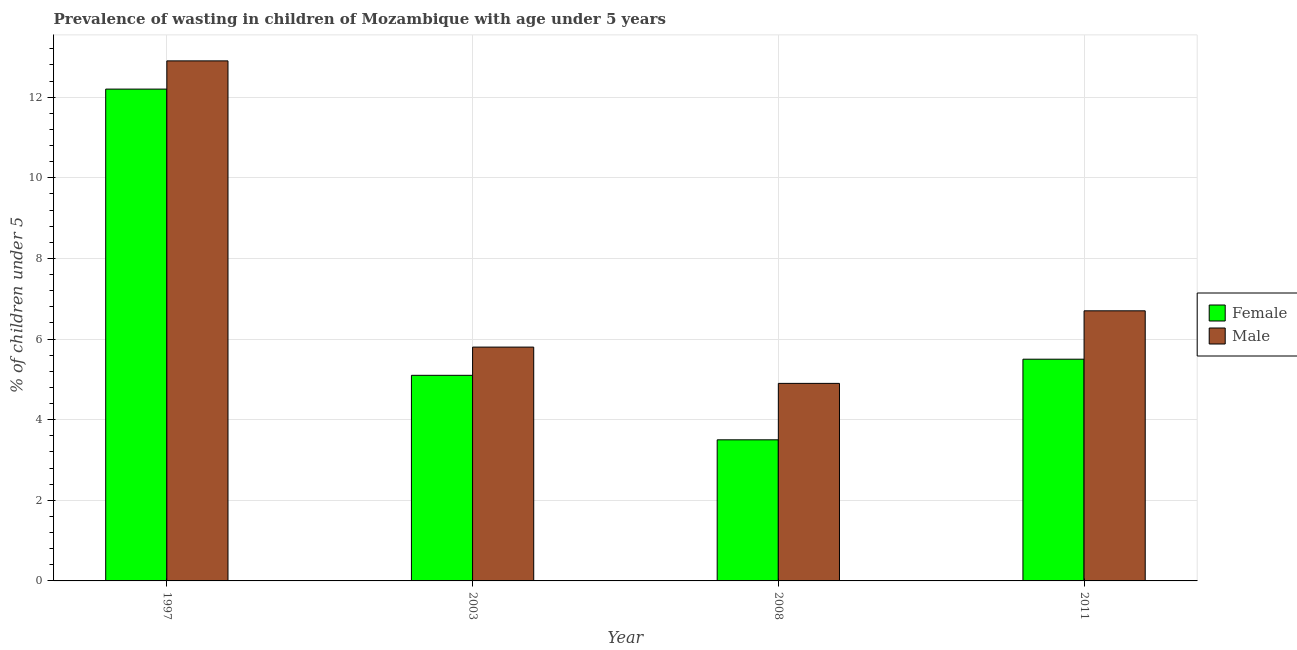How many different coloured bars are there?
Offer a very short reply. 2. How many groups of bars are there?
Offer a very short reply. 4. What is the percentage of undernourished female children in 2011?
Your response must be concise. 5.5. Across all years, what is the maximum percentage of undernourished female children?
Provide a succinct answer. 12.2. In which year was the percentage of undernourished male children maximum?
Your answer should be compact. 1997. In which year was the percentage of undernourished female children minimum?
Offer a very short reply. 2008. What is the total percentage of undernourished female children in the graph?
Your answer should be compact. 26.3. What is the difference between the percentage of undernourished female children in 1997 and that in 2008?
Ensure brevity in your answer.  8.7. What is the difference between the percentage of undernourished male children in 1997 and the percentage of undernourished female children in 2003?
Your response must be concise. 7.1. What is the average percentage of undernourished female children per year?
Your answer should be compact. 6.57. In how many years, is the percentage of undernourished female children greater than 2.8 %?
Offer a very short reply. 4. What is the ratio of the percentage of undernourished male children in 1997 to that in 2003?
Your answer should be very brief. 2.22. Is the percentage of undernourished male children in 2003 less than that in 2008?
Your answer should be very brief. No. What is the difference between the highest and the second highest percentage of undernourished male children?
Offer a terse response. 6.2. What is the difference between the highest and the lowest percentage of undernourished female children?
Keep it short and to the point. 8.7. In how many years, is the percentage of undernourished female children greater than the average percentage of undernourished female children taken over all years?
Provide a succinct answer. 1. Is the sum of the percentage of undernourished male children in 1997 and 2008 greater than the maximum percentage of undernourished female children across all years?
Your answer should be compact. Yes. What does the 2nd bar from the left in 1997 represents?
Your answer should be compact. Male. Are all the bars in the graph horizontal?
Ensure brevity in your answer.  No. How many years are there in the graph?
Your response must be concise. 4. Does the graph contain grids?
Give a very brief answer. Yes. Where does the legend appear in the graph?
Give a very brief answer. Center right. How many legend labels are there?
Give a very brief answer. 2. What is the title of the graph?
Your answer should be very brief. Prevalence of wasting in children of Mozambique with age under 5 years. Does "Private creditors" appear as one of the legend labels in the graph?
Your response must be concise. No. What is the label or title of the X-axis?
Give a very brief answer. Year. What is the label or title of the Y-axis?
Give a very brief answer.  % of children under 5. What is the  % of children under 5 of Female in 1997?
Provide a short and direct response. 12.2. What is the  % of children under 5 of Male in 1997?
Provide a succinct answer. 12.9. What is the  % of children under 5 of Female in 2003?
Ensure brevity in your answer.  5.1. What is the  % of children under 5 in Male in 2003?
Provide a short and direct response. 5.8. What is the  % of children under 5 of Male in 2008?
Your answer should be compact. 4.9. What is the  % of children under 5 of Female in 2011?
Provide a succinct answer. 5.5. What is the  % of children under 5 in Male in 2011?
Your response must be concise. 6.7. Across all years, what is the maximum  % of children under 5 in Female?
Your response must be concise. 12.2. Across all years, what is the maximum  % of children under 5 in Male?
Offer a very short reply. 12.9. Across all years, what is the minimum  % of children under 5 in Female?
Your answer should be very brief. 3.5. Across all years, what is the minimum  % of children under 5 of Male?
Offer a very short reply. 4.9. What is the total  % of children under 5 in Female in the graph?
Your answer should be very brief. 26.3. What is the total  % of children under 5 of Male in the graph?
Provide a succinct answer. 30.3. What is the difference between the  % of children under 5 in Female in 1997 and that in 2003?
Give a very brief answer. 7.1. What is the difference between the  % of children under 5 in Male in 1997 and that in 2003?
Your answer should be very brief. 7.1. What is the difference between the  % of children under 5 in Male in 1997 and that in 2008?
Provide a short and direct response. 8. What is the difference between the  % of children under 5 in Male in 1997 and that in 2011?
Keep it short and to the point. 6.2. What is the difference between the  % of children under 5 in Male in 2003 and that in 2008?
Keep it short and to the point. 0.9. What is the difference between the  % of children under 5 of Male in 2003 and that in 2011?
Give a very brief answer. -0.9. What is the difference between the  % of children under 5 in Female in 2008 and that in 2011?
Offer a very short reply. -2. What is the difference between the  % of children under 5 in Female in 1997 and the  % of children under 5 in Male in 2003?
Offer a very short reply. 6.4. What is the difference between the  % of children under 5 in Female in 1997 and the  % of children under 5 in Male in 2011?
Give a very brief answer. 5.5. What is the difference between the  % of children under 5 in Female in 2003 and the  % of children under 5 in Male in 2008?
Keep it short and to the point. 0.2. What is the difference between the  % of children under 5 in Female in 2003 and the  % of children under 5 in Male in 2011?
Keep it short and to the point. -1.6. What is the average  % of children under 5 of Female per year?
Offer a very short reply. 6.58. What is the average  % of children under 5 in Male per year?
Your response must be concise. 7.58. In the year 2003, what is the difference between the  % of children under 5 of Female and  % of children under 5 of Male?
Provide a succinct answer. -0.7. In the year 2008, what is the difference between the  % of children under 5 in Female and  % of children under 5 in Male?
Your response must be concise. -1.4. What is the ratio of the  % of children under 5 in Female in 1997 to that in 2003?
Your response must be concise. 2.39. What is the ratio of the  % of children under 5 of Male in 1997 to that in 2003?
Your answer should be compact. 2.22. What is the ratio of the  % of children under 5 in Female in 1997 to that in 2008?
Keep it short and to the point. 3.49. What is the ratio of the  % of children under 5 in Male in 1997 to that in 2008?
Make the answer very short. 2.63. What is the ratio of the  % of children under 5 of Female in 1997 to that in 2011?
Offer a terse response. 2.22. What is the ratio of the  % of children under 5 in Male in 1997 to that in 2011?
Make the answer very short. 1.93. What is the ratio of the  % of children under 5 in Female in 2003 to that in 2008?
Give a very brief answer. 1.46. What is the ratio of the  % of children under 5 in Male in 2003 to that in 2008?
Make the answer very short. 1.18. What is the ratio of the  % of children under 5 of Female in 2003 to that in 2011?
Make the answer very short. 0.93. What is the ratio of the  % of children under 5 of Male in 2003 to that in 2011?
Provide a succinct answer. 0.87. What is the ratio of the  % of children under 5 in Female in 2008 to that in 2011?
Keep it short and to the point. 0.64. What is the ratio of the  % of children under 5 of Male in 2008 to that in 2011?
Give a very brief answer. 0.73. What is the difference between the highest and the second highest  % of children under 5 in Male?
Offer a very short reply. 6.2. What is the difference between the highest and the lowest  % of children under 5 of Male?
Your response must be concise. 8. 